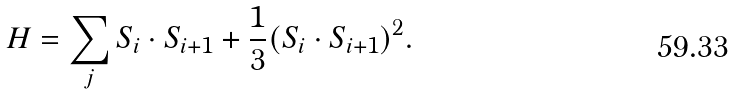<formula> <loc_0><loc_0><loc_500><loc_500>H = \sum _ { j } S _ { i } \cdot S _ { i + 1 } + \frac { 1 } { 3 } ( S _ { i } \cdot S _ { i + 1 } ) ^ { 2 } .</formula> 